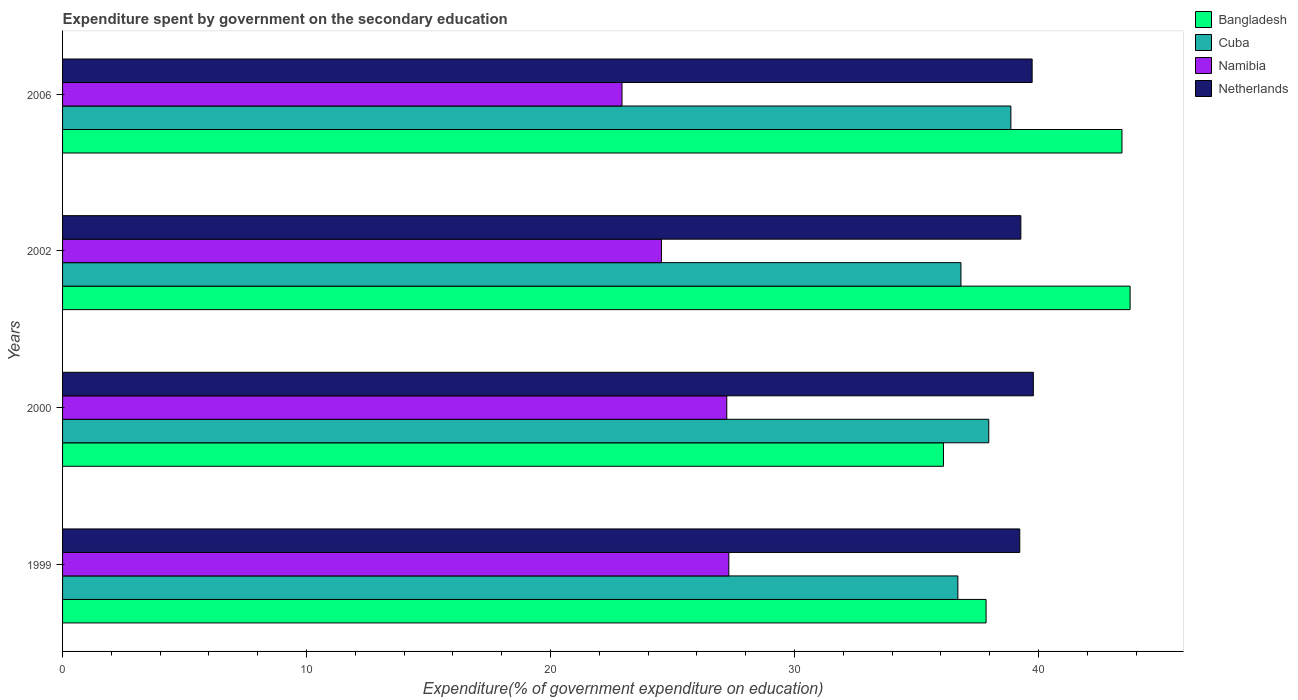How many different coloured bars are there?
Your answer should be very brief. 4. Are the number of bars per tick equal to the number of legend labels?
Your answer should be compact. Yes. How many bars are there on the 2nd tick from the bottom?
Provide a short and direct response. 4. In how many cases, is the number of bars for a given year not equal to the number of legend labels?
Your response must be concise. 0. What is the expenditure spent by government on the secondary education in Bangladesh in 1999?
Your answer should be very brief. 37.85. Across all years, what is the maximum expenditure spent by government on the secondary education in Netherlands?
Ensure brevity in your answer.  39.79. Across all years, what is the minimum expenditure spent by government on the secondary education in Bangladesh?
Your answer should be very brief. 36.11. What is the total expenditure spent by government on the secondary education in Netherlands in the graph?
Your answer should be compact. 158.04. What is the difference between the expenditure spent by government on the secondary education in Bangladesh in 1999 and that in 2002?
Give a very brief answer. -5.9. What is the difference between the expenditure spent by government on the secondary education in Namibia in 2006 and the expenditure spent by government on the secondary education in Bangladesh in 2000?
Provide a succinct answer. -13.18. What is the average expenditure spent by government on the secondary education in Bangladesh per year?
Your answer should be compact. 40.28. In the year 1999, what is the difference between the expenditure spent by government on the secondary education in Netherlands and expenditure spent by government on the secondary education in Cuba?
Provide a short and direct response. 2.54. In how many years, is the expenditure spent by government on the secondary education in Bangladesh greater than 16 %?
Provide a succinct answer. 4. What is the ratio of the expenditure spent by government on the secondary education in Namibia in 2000 to that in 2002?
Your answer should be compact. 1.11. Is the difference between the expenditure spent by government on the secondary education in Netherlands in 1999 and 2002 greater than the difference between the expenditure spent by government on the secondary education in Cuba in 1999 and 2002?
Offer a very short reply. Yes. What is the difference between the highest and the second highest expenditure spent by government on the secondary education in Bangladesh?
Provide a succinct answer. 0.33. What is the difference between the highest and the lowest expenditure spent by government on the secondary education in Namibia?
Your answer should be very brief. 4.38. Is the sum of the expenditure spent by government on the secondary education in Bangladesh in 2002 and 2006 greater than the maximum expenditure spent by government on the secondary education in Namibia across all years?
Offer a very short reply. Yes. Is it the case that in every year, the sum of the expenditure spent by government on the secondary education in Namibia and expenditure spent by government on the secondary education in Netherlands is greater than the sum of expenditure spent by government on the secondary education in Bangladesh and expenditure spent by government on the secondary education in Cuba?
Keep it short and to the point. No. What does the 2nd bar from the top in 1999 represents?
Ensure brevity in your answer.  Namibia. What does the 3rd bar from the bottom in 1999 represents?
Your answer should be compact. Namibia. Is it the case that in every year, the sum of the expenditure spent by government on the secondary education in Namibia and expenditure spent by government on the secondary education in Netherlands is greater than the expenditure spent by government on the secondary education in Bangladesh?
Make the answer very short. Yes. How many bars are there?
Your answer should be compact. 16. What is the difference between two consecutive major ticks on the X-axis?
Offer a terse response. 10. Are the values on the major ticks of X-axis written in scientific E-notation?
Provide a short and direct response. No. Does the graph contain any zero values?
Make the answer very short. No. What is the title of the graph?
Your answer should be compact. Expenditure spent by government on the secondary education. Does "Dominica" appear as one of the legend labels in the graph?
Make the answer very short. No. What is the label or title of the X-axis?
Keep it short and to the point. Expenditure(% of government expenditure on education). What is the label or title of the Y-axis?
Your answer should be compact. Years. What is the Expenditure(% of government expenditure on education) of Bangladesh in 1999?
Keep it short and to the point. 37.85. What is the Expenditure(% of government expenditure on education) of Cuba in 1999?
Make the answer very short. 36.7. What is the Expenditure(% of government expenditure on education) of Namibia in 1999?
Offer a very short reply. 27.31. What is the Expenditure(% of government expenditure on education) of Netherlands in 1999?
Offer a terse response. 39.23. What is the Expenditure(% of government expenditure on education) of Bangladesh in 2000?
Provide a succinct answer. 36.11. What is the Expenditure(% of government expenditure on education) in Cuba in 2000?
Provide a succinct answer. 37.96. What is the Expenditure(% of government expenditure on education) in Namibia in 2000?
Give a very brief answer. 27.22. What is the Expenditure(% of government expenditure on education) of Netherlands in 2000?
Your answer should be compact. 39.79. What is the Expenditure(% of government expenditure on education) in Bangladesh in 2002?
Ensure brevity in your answer.  43.76. What is the Expenditure(% of government expenditure on education) of Cuba in 2002?
Ensure brevity in your answer.  36.82. What is the Expenditure(% of government expenditure on education) in Namibia in 2002?
Provide a succinct answer. 24.55. What is the Expenditure(% of government expenditure on education) in Netherlands in 2002?
Your answer should be compact. 39.28. What is the Expenditure(% of government expenditure on education) of Bangladesh in 2006?
Provide a short and direct response. 43.42. What is the Expenditure(% of government expenditure on education) in Cuba in 2006?
Offer a very short reply. 38.87. What is the Expenditure(% of government expenditure on education) in Namibia in 2006?
Provide a succinct answer. 22.93. What is the Expenditure(% of government expenditure on education) of Netherlands in 2006?
Offer a terse response. 39.74. Across all years, what is the maximum Expenditure(% of government expenditure on education) in Bangladesh?
Offer a very short reply. 43.76. Across all years, what is the maximum Expenditure(% of government expenditure on education) in Cuba?
Keep it short and to the point. 38.87. Across all years, what is the maximum Expenditure(% of government expenditure on education) in Namibia?
Provide a succinct answer. 27.31. Across all years, what is the maximum Expenditure(% of government expenditure on education) in Netherlands?
Offer a very short reply. 39.79. Across all years, what is the minimum Expenditure(% of government expenditure on education) in Bangladesh?
Keep it short and to the point. 36.11. Across all years, what is the minimum Expenditure(% of government expenditure on education) of Cuba?
Offer a terse response. 36.7. Across all years, what is the minimum Expenditure(% of government expenditure on education) of Namibia?
Make the answer very short. 22.93. Across all years, what is the minimum Expenditure(% of government expenditure on education) in Netherlands?
Your answer should be compact. 39.23. What is the total Expenditure(% of government expenditure on education) of Bangladesh in the graph?
Your answer should be very brief. 161.14. What is the total Expenditure(% of government expenditure on education) of Cuba in the graph?
Offer a terse response. 150.35. What is the total Expenditure(% of government expenditure on education) in Namibia in the graph?
Give a very brief answer. 102.01. What is the total Expenditure(% of government expenditure on education) of Netherlands in the graph?
Give a very brief answer. 158.04. What is the difference between the Expenditure(% of government expenditure on education) of Bangladesh in 1999 and that in 2000?
Provide a succinct answer. 1.75. What is the difference between the Expenditure(% of government expenditure on education) in Cuba in 1999 and that in 2000?
Your answer should be compact. -1.27. What is the difference between the Expenditure(% of government expenditure on education) in Namibia in 1999 and that in 2000?
Your response must be concise. 0.08. What is the difference between the Expenditure(% of government expenditure on education) in Netherlands in 1999 and that in 2000?
Your answer should be very brief. -0.56. What is the difference between the Expenditure(% of government expenditure on education) of Bangladesh in 1999 and that in 2002?
Your response must be concise. -5.9. What is the difference between the Expenditure(% of government expenditure on education) in Cuba in 1999 and that in 2002?
Your response must be concise. -0.13. What is the difference between the Expenditure(% of government expenditure on education) of Namibia in 1999 and that in 2002?
Your response must be concise. 2.76. What is the difference between the Expenditure(% of government expenditure on education) of Netherlands in 1999 and that in 2002?
Your answer should be compact. -0.04. What is the difference between the Expenditure(% of government expenditure on education) in Bangladesh in 1999 and that in 2006?
Your response must be concise. -5.57. What is the difference between the Expenditure(% of government expenditure on education) of Cuba in 1999 and that in 2006?
Provide a succinct answer. -2.17. What is the difference between the Expenditure(% of government expenditure on education) in Namibia in 1999 and that in 2006?
Your answer should be very brief. 4.38. What is the difference between the Expenditure(% of government expenditure on education) in Netherlands in 1999 and that in 2006?
Keep it short and to the point. -0.51. What is the difference between the Expenditure(% of government expenditure on education) in Bangladesh in 2000 and that in 2002?
Offer a terse response. -7.65. What is the difference between the Expenditure(% of government expenditure on education) of Cuba in 2000 and that in 2002?
Make the answer very short. 1.14. What is the difference between the Expenditure(% of government expenditure on education) of Namibia in 2000 and that in 2002?
Provide a succinct answer. 2.68. What is the difference between the Expenditure(% of government expenditure on education) of Netherlands in 2000 and that in 2002?
Offer a very short reply. 0.51. What is the difference between the Expenditure(% of government expenditure on education) in Bangladesh in 2000 and that in 2006?
Provide a succinct answer. -7.32. What is the difference between the Expenditure(% of government expenditure on education) in Cuba in 2000 and that in 2006?
Your response must be concise. -0.91. What is the difference between the Expenditure(% of government expenditure on education) of Namibia in 2000 and that in 2006?
Offer a terse response. 4.29. What is the difference between the Expenditure(% of government expenditure on education) of Netherlands in 2000 and that in 2006?
Give a very brief answer. 0.05. What is the difference between the Expenditure(% of government expenditure on education) in Bangladesh in 2002 and that in 2006?
Make the answer very short. 0.33. What is the difference between the Expenditure(% of government expenditure on education) of Cuba in 2002 and that in 2006?
Provide a succinct answer. -2.05. What is the difference between the Expenditure(% of government expenditure on education) in Namibia in 2002 and that in 2006?
Give a very brief answer. 1.62. What is the difference between the Expenditure(% of government expenditure on education) in Netherlands in 2002 and that in 2006?
Offer a terse response. -0.46. What is the difference between the Expenditure(% of government expenditure on education) of Bangladesh in 1999 and the Expenditure(% of government expenditure on education) of Cuba in 2000?
Provide a short and direct response. -0.11. What is the difference between the Expenditure(% of government expenditure on education) of Bangladesh in 1999 and the Expenditure(% of government expenditure on education) of Namibia in 2000?
Make the answer very short. 10.63. What is the difference between the Expenditure(% of government expenditure on education) in Bangladesh in 1999 and the Expenditure(% of government expenditure on education) in Netherlands in 2000?
Provide a short and direct response. -1.94. What is the difference between the Expenditure(% of government expenditure on education) in Cuba in 1999 and the Expenditure(% of government expenditure on education) in Namibia in 2000?
Ensure brevity in your answer.  9.47. What is the difference between the Expenditure(% of government expenditure on education) in Cuba in 1999 and the Expenditure(% of government expenditure on education) in Netherlands in 2000?
Offer a very short reply. -3.09. What is the difference between the Expenditure(% of government expenditure on education) of Namibia in 1999 and the Expenditure(% of government expenditure on education) of Netherlands in 2000?
Keep it short and to the point. -12.48. What is the difference between the Expenditure(% of government expenditure on education) in Bangladesh in 1999 and the Expenditure(% of government expenditure on education) in Cuba in 2002?
Your answer should be compact. 1.03. What is the difference between the Expenditure(% of government expenditure on education) in Bangladesh in 1999 and the Expenditure(% of government expenditure on education) in Namibia in 2002?
Your answer should be very brief. 13.31. What is the difference between the Expenditure(% of government expenditure on education) in Bangladesh in 1999 and the Expenditure(% of government expenditure on education) in Netherlands in 2002?
Keep it short and to the point. -1.42. What is the difference between the Expenditure(% of government expenditure on education) of Cuba in 1999 and the Expenditure(% of government expenditure on education) of Namibia in 2002?
Your response must be concise. 12.15. What is the difference between the Expenditure(% of government expenditure on education) of Cuba in 1999 and the Expenditure(% of government expenditure on education) of Netherlands in 2002?
Give a very brief answer. -2.58. What is the difference between the Expenditure(% of government expenditure on education) in Namibia in 1999 and the Expenditure(% of government expenditure on education) in Netherlands in 2002?
Your response must be concise. -11.97. What is the difference between the Expenditure(% of government expenditure on education) in Bangladesh in 1999 and the Expenditure(% of government expenditure on education) in Cuba in 2006?
Offer a very short reply. -1.02. What is the difference between the Expenditure(% of government expenditure on education) in Bangladesh in 1999 and the Expenditure(% of government expenditure on education) in Namibia in 2006?
Offer a very short reply. 14.92. What is the difference between the Expenditure(% of government expenditure on education) of Bangladesh in 1999 and the Expenditure(% of government expenditure on education) of Netherlands in 2006?
Your answer should be compact. -1.89. What is the difference between the Expenditure(% of government expenditure on education) of Cuba in 1999 and the Expenditure(% of government expenditure on education) of Namibia in 2006?
Offer a very short reply. 13.77. What is the difference between the Expenditure(% of government expenditure on education) of Cuba in 1999 and the Expenditure(% of government expenditure on education) of Netherlands in 2006?
Provide a succinct answer. -3.04. What is the difference between the Expenditure(% of government expenditure on education) of Namibia in 1999 and the Expenditure(% of government expenditure on education) of Netherlands in 2006?
Keep it short and to the point. -12.43. What is the difference between the Expenditure(% of government expenditure on education) of Bangladesh in 2000 and the Expenditure(% of government expenditure on education) of Cuba in 2002?
Offer a terse response. -0.72. What is the difference between the Expenditure(% of government expenditure on education) in Bangladesh in 2000 and the Expenditure(% of government expenditure on education) in Namibia in 2002?
Provide a succinct answer. 11.56. What is the difference between the Expenditure(% of government expenditure on education) in Bangladesh in 2000 and the Expenditure(% of government expenditure on education) in Netherlands in 2002?
Offer a very short reply. -3.17. What is the difference between the Expenditure(% of government expenditure on education) of Cuba in 2000 and the Expenditure(% of government expenditure on education) of Namibia in 2002?
Offer a very short reply. 13.42. What is the difference between the Expenditure(% of government expenditure on education) of Cuba in 2000 and the Expenditure(% of government expenditure on education) of Netherlands in 2002?
Make the answer very short. -1.31. What is the difference between the Expenditure(% of government expenditure on education) of Namibia in 2000 and the Expenditure(% of government expenditure on education) of Netherlands in 2002?
Make the answer very short. -12.05. What is the difference between the Expenditure(% of government expenditure on education) of Bangladesh in 2000 and the Expenditure(% of government expenditure on education) of Cuba in 2006?
Offer a very short reply. -2.76. What is the difference between the Expenditure(% of government expenditure on education) of Bangladesh in 2000 and the Expenditure(% of government expenditure on education) of Namibia in 2006?
Give a very brief answer. 13.18. What is the difference between the Expenditure(% of government expenditure on education) of Bangladesh in 2000 and the Expenditure(% of government expenditure on education) of Netherlands in 2006?
Offer a very short reply. -3.63. What is the difference between the Expenditure(% of government expenditure on education) of Cuba in 2000 and the Expenditure(% of government expenditure on education) of Namibia in 2006?
Give a very brief answer. 15.03. What is the difference between the Expenditure(% of government expenditure on education) in Cuba in 2000 and the Expenditure(% of government expenditure on education) in Netherlands in 2006?
Ensure brevity in your answer.  -1.78. What is the difference between the Expenditure(% of government expenditure on education) in Namibia in 2000 and the Expenditure(% of government expenditure on education) in Netherlands in 2006?
Your answer should be very brief. -12.52. What is the difference between the Expenditure(% of government expenditure on education) of Bangladesh in 2002 and the Expenditure(% of government expenditure on education) of Cuba in 2006?
Your response must be concise. 4.89. What is the difference between the Expenditure(% of government expenditure on education) of Bangladesh in 2002 and the Expenditure(% of government expenditure on education) of Namibia in 2006?
Provide a succinct answer. 20.83. What is the difference between the Expenditure(% of government expenditure on education) of Bangladesh in 2002 and the Expenditure(% of government expenditure on education) of Netherlands in 2006?
Make the answer very short. 4.02. What is the difference between the Expenditure(% of government expenditure on education) in Cuba in 2002 and the Expenditure(% of government expenditure on education) in Namibia in 2006?
Give a very brief answer. 13.89. What is the difference between the Expenditure(% of government expenditure on education) in Cuba in 2002 and the Expenditure(% of government expenditure on education) in Netherlands in 2006?
Give a very brief answer. -2.92. What is the difference between the Expenditure(% of government expenditure on education) of Namibia in 2002 and the Expenditure(% of government expenditure on education) of Netherlands in 2006?
Your answer should be compact. -15.19. What is the average Expenditure(% of government expenditure on education) of Bangladesh per year?
Keep it short and to the point. 40.28. What is the average Expenditure(% of government expenditure on education) of Cuba per year?
Keep it short and to the point. 37.59. What is the average Expenditure(% of government expenditure on education) in Namibia per year?
Ensure brevity in your answer.  25.5. What is the average Expenditure(% of government expenditure on education) in Netherlands per year?
Give a very brief answer. 39.51. In the year 1999, what is the difference between the Expenditure(% of government expenditure on education) in Bangladesh and Expenditure(% of government expenditure on education) in Cuba?
Provide a short and direct response. 1.16. In the year 1999, what is the difference between the Expenditure(% of government expenditure on education) in Bangladesh and Expenditure(% of government expenditure on education) in Namibia?
Keep it short and to the point. 10.54. In the year 1999, what is the difference between the Expenditure(% of government expenditure on education) in Bangladesh and Expenditure(% of government expenditure on education) in Netherlands?
Provide a succinct answer. -1.38. In the year 1999, what is the difference between the Expenditure(% of government expenditure on education) of Cuba and Expenditure(% of government expenditure on education) of Namibia?
Your answer should be very brief. 9.39. In the year 1999, what is the difference between the Expenditure(% of government expenditure on education) in Cuba and Expenditure(% of government expenditure on education) in Netherlands?
Give a very brief answer. -2.54. In the year 1999, what is the difference between the Expenditure(% of government expenditure on education) of Namibia and Expenditure(% of government expenditure on education) of Netherlands?
Make the answer very short. -11.92. In the year 2000, what is the difference between the Expenditure(% of government expenditure on education) of Bangladesh and Expenditure(% of government expenditure on education) of Cuba?
Offer a terse response. -1.86. In the year 2000, what is the difference between the Expenditure(% of government expenditure on education) in Bangladesh and Expenditure(% of government expenditure on education) in Namibia?
Provide a succinct answer. 8.88. In the year 2000, what is the difference between the Expenditure(% of government expenditure on education) in Bangladesh and Expenditure(% of government expenditure on education) in Netherlands?
Give a very brief answer. -3.68. In the year 2000, what is the difference between the Expenditure(% of government expenditure on education) in Cuba and Expenditure(% of government expenditure on education) in Namibia?
Keep it short and to the point. 10.74. In the year 2000, what is the difference between the Expenditure(% of government expenditure on education) of Cuba and Expenditure(% of government expenditure on education) of Netherlands?
Offer a very short reply. -1.83. In the year 2000, what is the difference between the Expenditure(% of government expenditure on education) of Namibia and Expenditure(% of government expenditure on education) of Netherlands?
Ensure brevity in your answer.  -12.57. In the year 2002, what is the difference between the Expenditure(% of government expenditure on education) in Bangladesh and Expenditure(% of government expenditure on education) in Cuba?
Make the answer very short. 6.93. In the year 2002, what is the difference between the Expenditure(% of government expenditure on education) in Bangladesh and Expenditure(% of government expenditure on education) in Namibia?
Your answer should be very brief. 19.21. In the year 2002, what is the difference between the Expenditure(% of government expenditure on education) of Bangladesh and Expenditure(% of government expenditure on education) of Netherlands?
Provide a succinct answer. 4.48. In the year 2002, what is the difference between the Expenditure(% of government expenditure on education) of Cuba and Expenditure(% of government expenditure on education) of Namibia?
Give a very brief answer. 12.28. In the year 2002, what is the difference between the Expenditure(% of government expenditure on education) of Cuba and Expenditure(% of government expenditure on education) of Netherlands?
Make the answer very short. -2.45. In the year 2002, what is the difference between the Expenditure(% of government expenditure on education) of Namibia and Expenditure(% of government expenditure on education) of Netherlands?
Your response must be concise. -14.73. In the year 2006, what is the difference between the Expenditure(% of government expenditure on education) in Bangladesh and Expenditure(% of government expenditure on education) in Cuba?
Your answer should be very brief. 4.55. In the year 2006, what is the difference between the Expenditure(% of government expenditure on education) of Bangladesh and Expenditure(% of government expenditure on education) of Namibia?
Offer a terse response. 20.49. In the year 2006, what is the difference between the Expenditure(% of government expenditure on education) of Bangladesh and Expenditure(% of government expenditure on education) of Netherlands?
Make the answer very short. 3.68. In the year 2006, what is the difference between the Expenditure(% of government expenditure on education) in Cuba and Expenditure(% of government expenditure on education) in Namibia?
Your answer should be compact. 15.94. In the year 2006, what is the difference between the Expenditure(% of government expenditure on education) of Cuba and Expenditure(% of government expenditure on education) of Netherlands?
Ensure brevity in your answer.  -0.87. In the year 2006, what is the difference between the Expenditure(% of government expenditure on education) of Namibia and Expenditure(% of government expenditure on education) of Netherlands?
Offer a terse response. -16.81. What is the ratio of the Expenditure(% of government expenditure on education) in Bangladesh in 1999 to that in 2000?
Provide a short and direct response. 1.05. What is the ratio of the Expenditure(% of government expenditure on education) in Cuba in 1999 to that in 2000?
Provide a succinct answer. 0.97. What is the ratio of the Expenditure(% of government expenditure on education) in Namibia in 1999 to that in 2000?
Provide a short and direct response. 1. What is the ratio of the Expenditure(% of government expenditure on education) in Bangladesh in 1999 to that in 2002?
Ensure brevity in your answer.  0.87. What is the ratio of the Expenditure(% of government expenditure on education) of Cuba in 1999 to that in 2002?
Your answer should be very brief. 1. What is the ratio of the Expenditure(% of government expenditure on education) in Namibia in 1999 to that in 2002?
Ensure brevity in your answer.  1.11. What is the ratio of the Expenditure(% of government expenditure on education) in Bangladesh in 1999 to that in 2006?
Make the answer very short. 0.87. What is the ratio of the Expenditure(% of government expenditure on education) of Cuba in 1999 to that in 2006?
Your response must be concise. 0.94. What is the ratio of the Expenditure(% of government expenditure on education) of Namibia in 1999 to that in 2006?
Provide a short and direct response. 1.19. What is the ratio of the Expenditure(% of government expenditure on education) of Netherlands in 1999 to that in 2006?
Make the answer very short. 0.99. What is the ratio of the Expenditure(% of government expenditure on education) of Bangladesh in 2000 to that in 2002?
Ensure brevity in your answer.  0.83. What is the ratio of the Expenditure(% of government expenditure on education) in Cuba in 2000 to that in 2002?
Offer a terse response. 1.03. What is the ratio of the Expenditure(% of government expenditure on education) in Namibia in 2000 to that in 2002?
Offer a terse response. 1.11. What is the ratio of the Expenditure(% of government expenditure on education) in Netherlands in 2000 to that in 2002?
Your response must be concise. 1.01. What is the ratio of the Expenditure(% of government expenditure on education) of Bangladesh in 2000 to that in 2006?
Keep it short and to the point. 0.83. What is the ratio of the Expenditure(% of government expenditure on education) of Cuba in 2000 to that in 2006?
Provide a succinct answer. 0.98. What is the ratio of the Expenditure(% of government expenditure on education) in Namibia in 2000 to that in 2006?
Provide a short and direct response. 1.19. What is the ratio of the Expenditure(% of government expenditure on education) in Netherlands in 2000 to that in 2006?
Provide a succinct answer. 1. What is the ratio of the Expenditure(% of government expenditure on education) in Bangladesh in 2002 to that in 2006?
Provide a short and direct response. 1.01. What is the ratio of the Expenditure(% of government expenditure on education) in Namibia in 2002 to that in 2006?
Keep it short and to the point. 1.07. What is the ratio of the Expenditure(% of government expenditure on education) in Netherlands in 2002 to that in 2006?
Your answer should be compact. 0.99. What is the difference between the highest and the second highest Expenditure(% of government expenditure on education) of Bangladesh?
Keep it short and to the point. 0.33. What is the difference between the highest and the second highest Expenditure(% of government expenditure on education) in Cuba?
Offer a very short reply. 0.91. What is the difference between the highest and the second highest Expenditure(% of government expenditure on education) in Namibia?
Offer a very short reply. 0.08. What is the difference between the highest and the second highest Expenditure(% of government expenditure on education) in Netherlands?
Your response must be concise. 0.05. What is the difference between the highest and the lowest Expenditure(% of government expenditure on education) in Bangladesh?
Provide a succinct answer. 7.65. What is the difference between the highest and the lowest Expenditure(% of government expenditure on education) in Cuba?
Your answer should be very brief. 2.17. What is the difference between the highest and the lowest Expenditure(% of government expenditure on education) in Namibia?
Ensure brevity in your answer.  4.38. What is the difference between the highest and the lowest Expenditure(% of government expenditure on education) of Netherlands?
Make the answer very short. 0.56. 